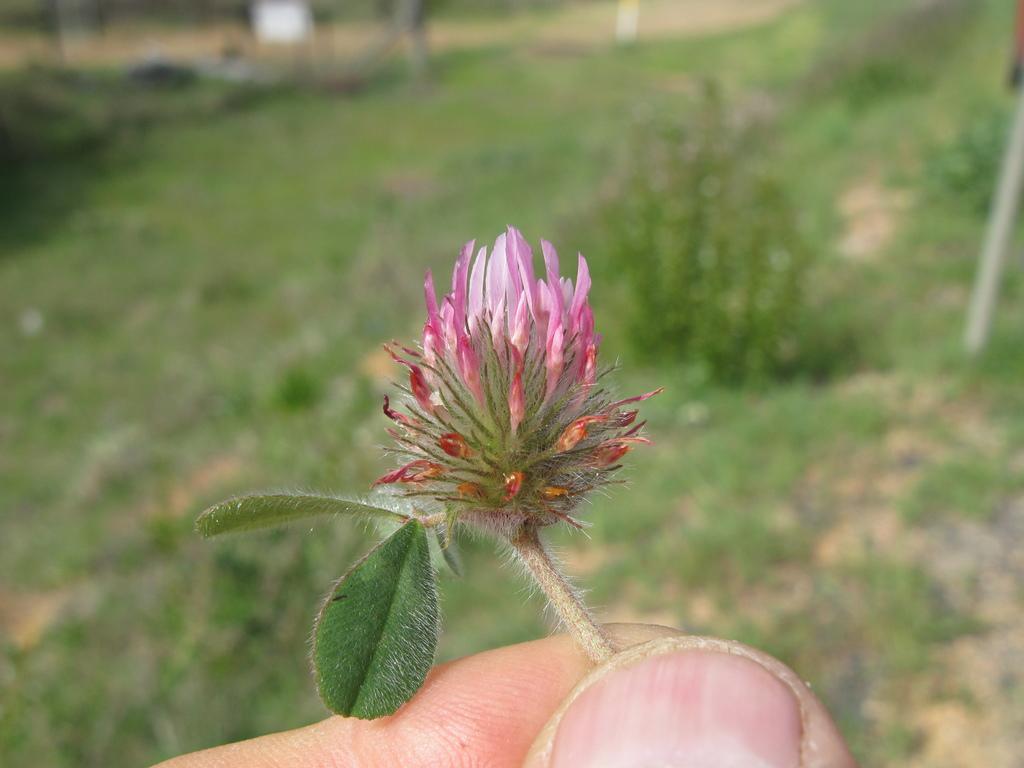How would you summarize this image in a sentence or two? In this image, we can see a person’s hand holding a flower. We can see the ground with some grass, plants and objects. 